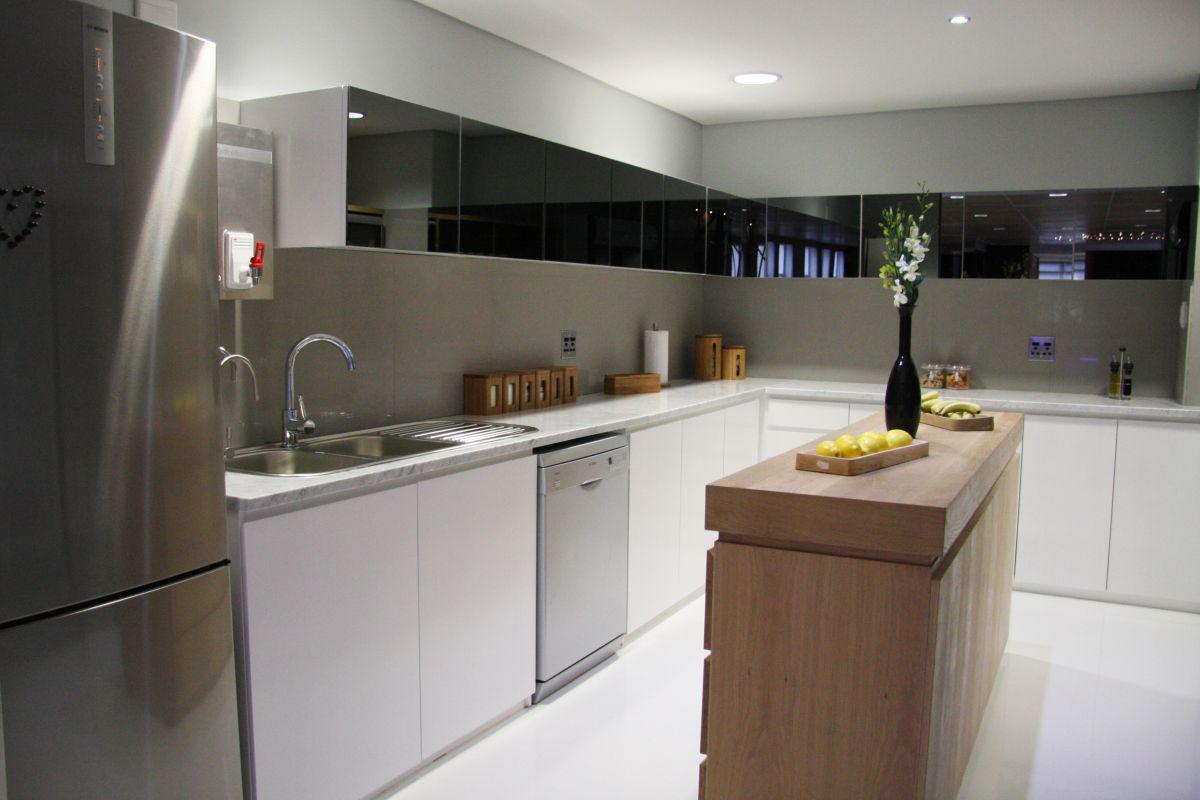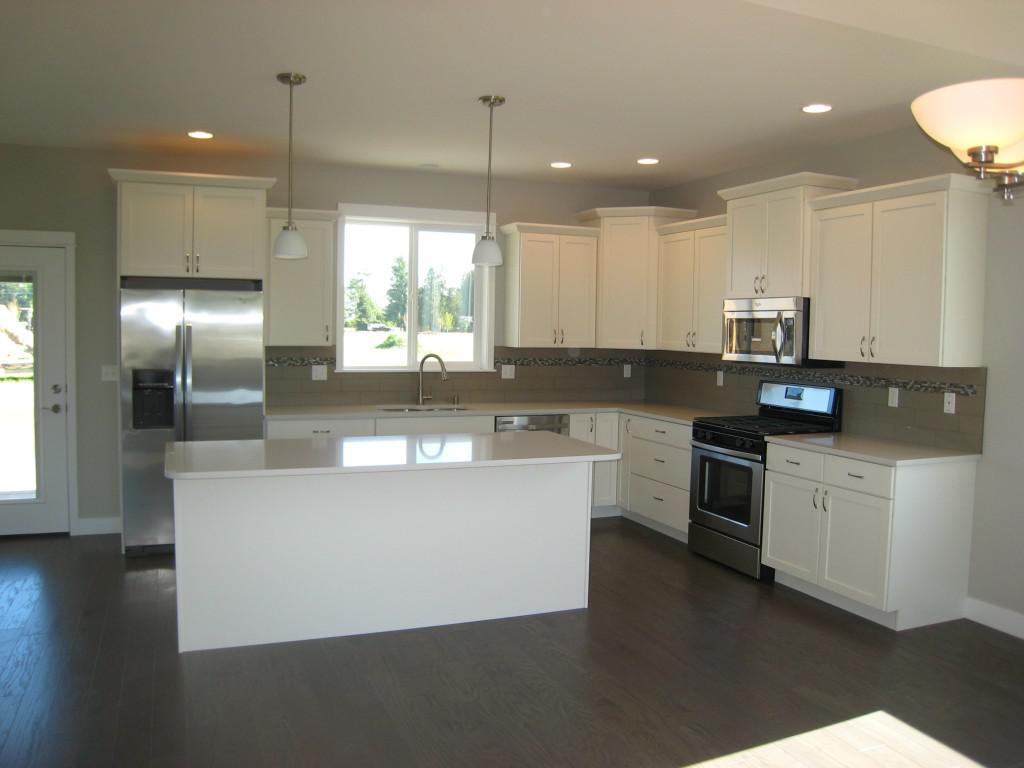The first image is the image on the left, the second image is the image on the right. Considering the images on both sides, is "A plant in a container is to the left of the kitchen sink." valid? Answer yes or no. No. The first image is the image on the left, the second image is the image on the right. Analyze the images presented: Is the assertion "Both kitchens have outside windows." valid? Answer yes or no. No. 